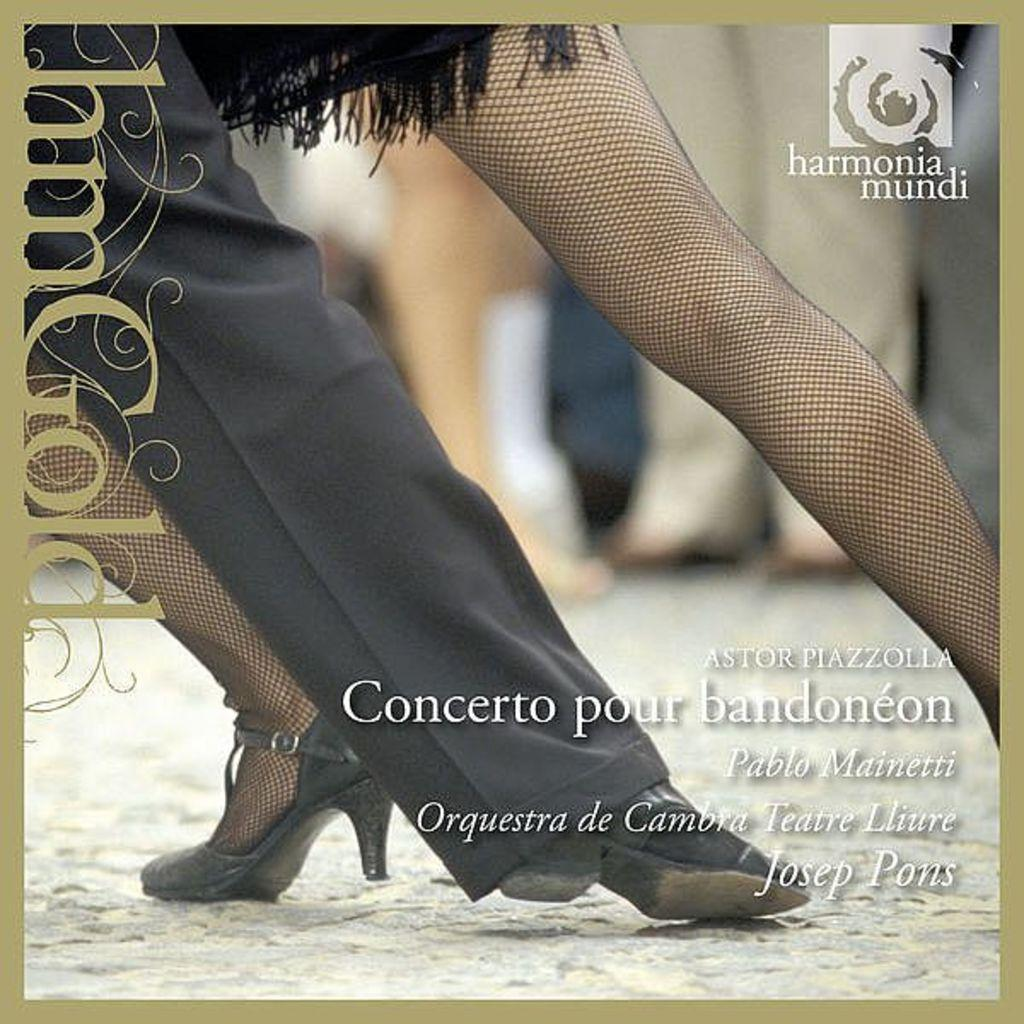What is featured in the image? There is a poster in the image. What is depicted on the poster? The poster contains the legs of a girl and a man. What type of fowl can be seen interacting with the metal in the image? There is no fowl or metal present in the image; it only features a poster with the legs of a girl and a man. 